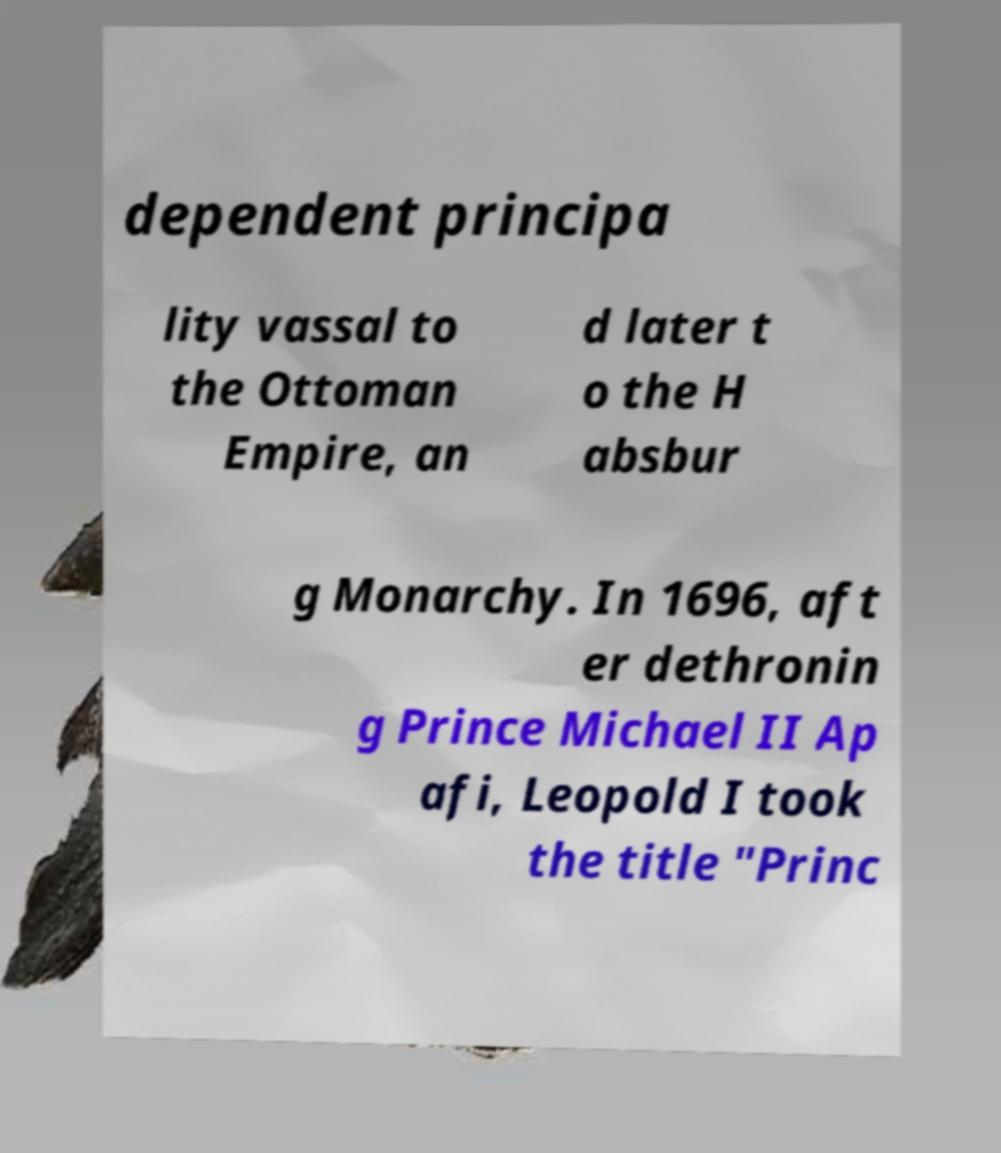Can you accurately transcribe the text from the provided image for me? dependent principa lity vassal to the Ottoman Empire, an d later t o the H absbur g Monarchy. In 1696, aft er dethronin g Prince Michael II Ap afi, Leopold I took the title "Princ 